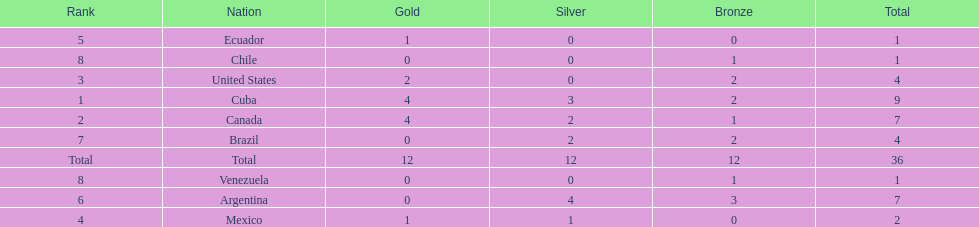Who had more silver medals, cuba or brazil? Cuba. 